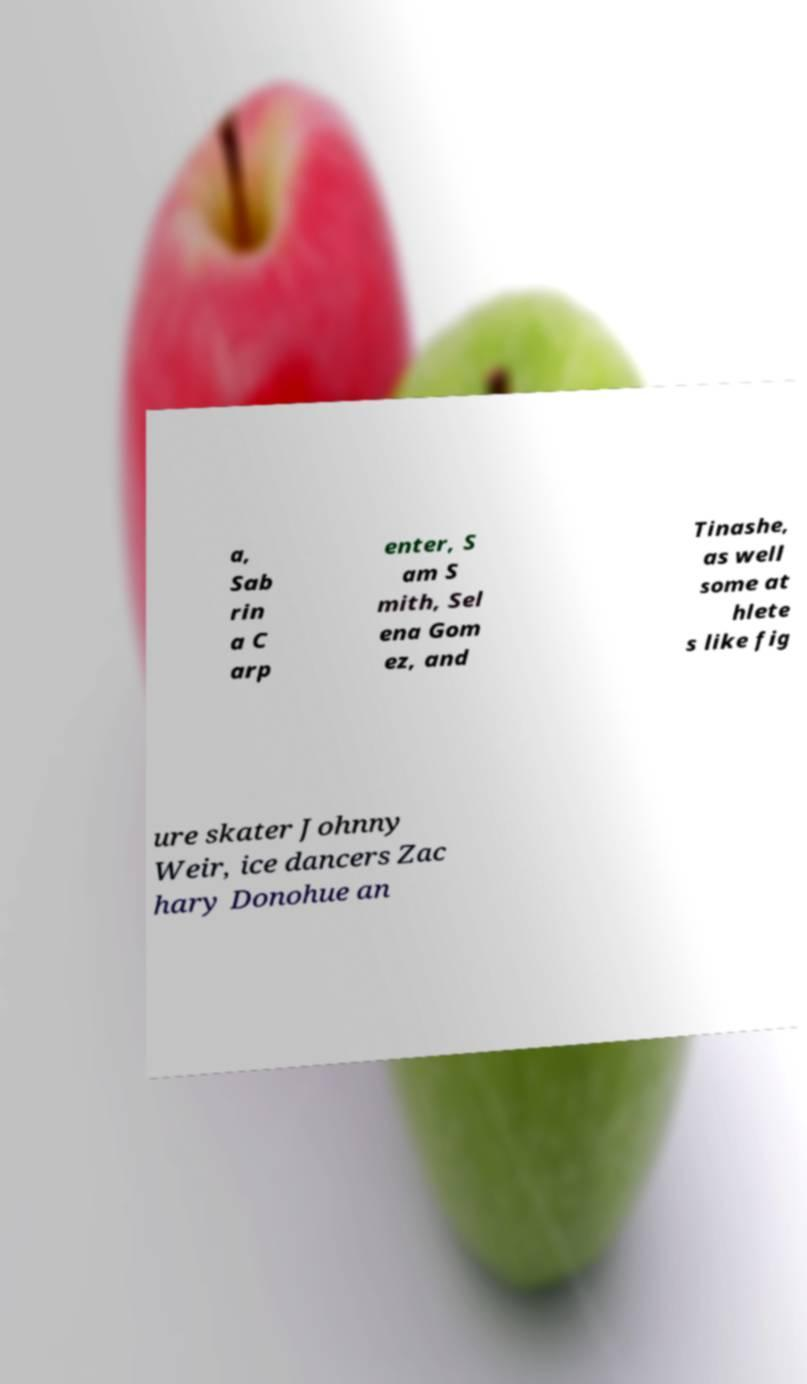Could you extract and type out the text from this image? a, Sab rin a C arp enter, S am S mith, Sel ena Gom ez, and Tinashe, as well some at hlete s like fig ure skater Johnny Weir, ice dancers Zac hary Donohue an 